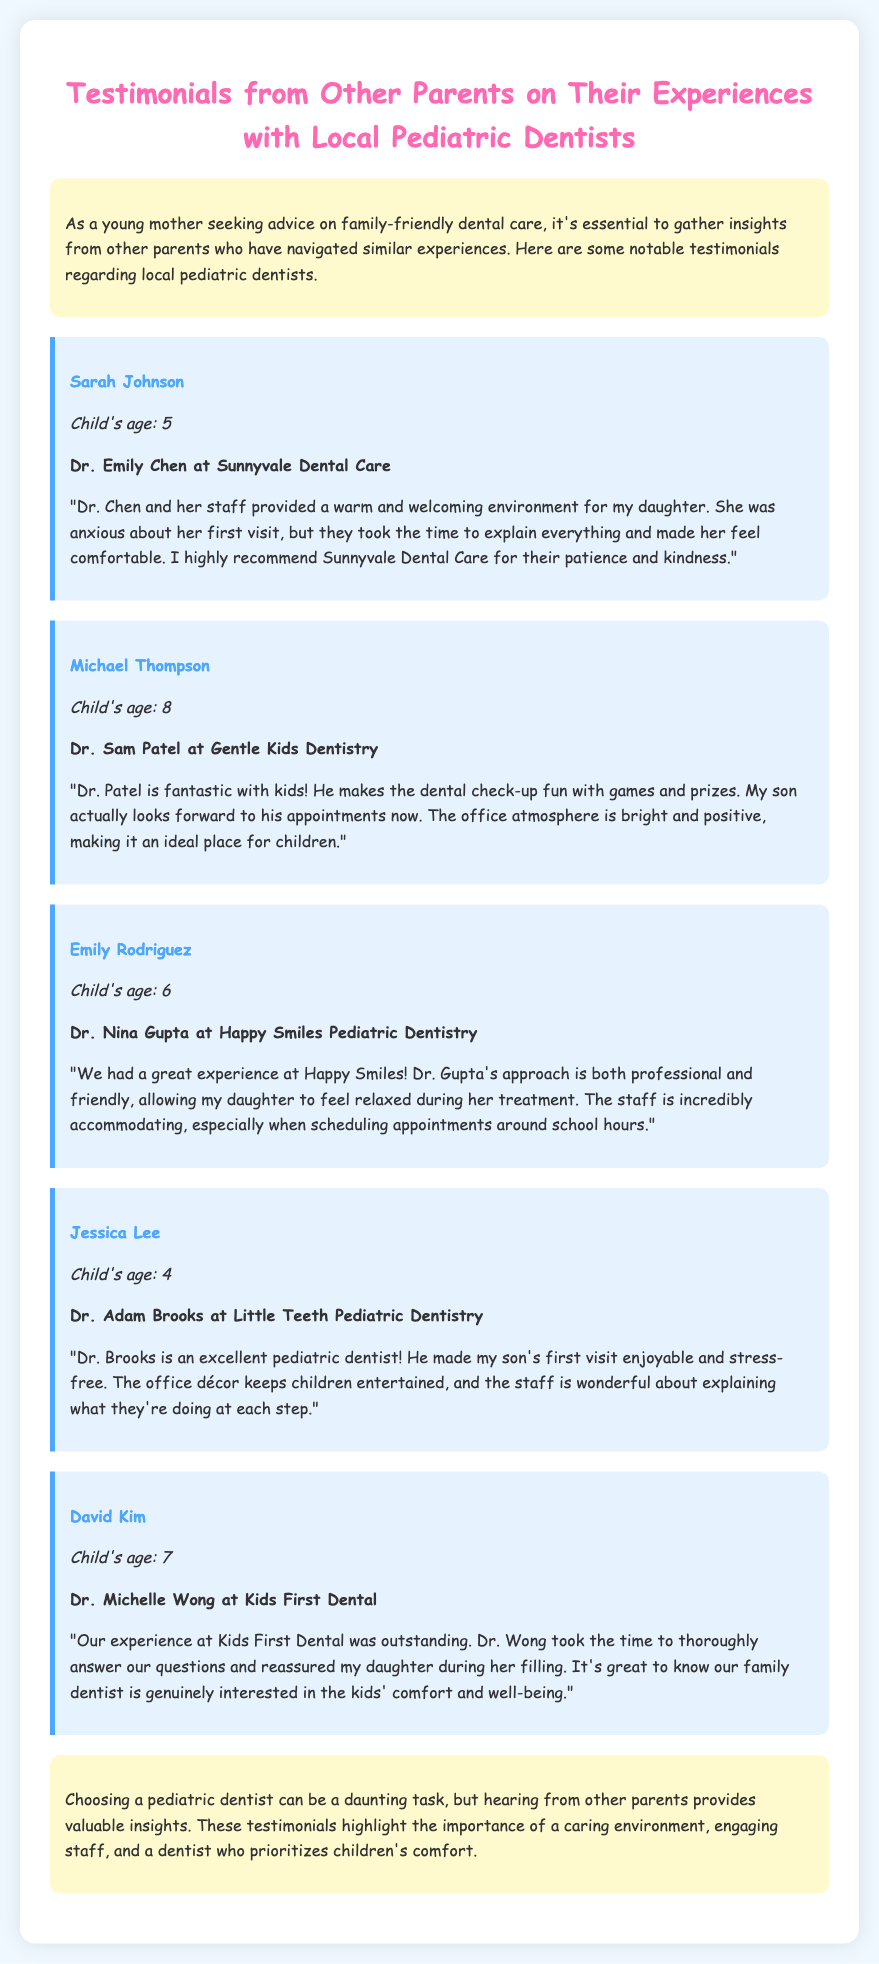What is the name of the first dentist mentioned? The first dentist mentioned in the document is Dr. Emily Chen at Sunnyvale Dental Care.
Answer: Dr. Emily Chen How old is Sarah Johnson's child? The document specifies that Sarah Johnson's child is 5 years old.
Answer: 5 Which pediatric dentist is associated with a fun atmosphere? Michael Thompson's testimonial highlights that Dr. Sam Patel creates a fun atmosphere during check-ups.
Answer: Dr. Sam Patel What was Jessica Lee's son's experience during his first visit? Jessica Lee mentions that her son's first visit was enjoyable and stress-free with Dr. Brooks.
Answer: Enjoyable and stress-free How many testimonials are included in the document? The document contains five testimonials from different parents regarding their experiences with pediatric dentists.
Answer: Five What is a common theme mentioned across the testimonials? The testimonials emphasize the importance of a caring environment and staff engagement for children's comfort.
Answer: Caring environment Which dentist provided a positive experience specifically for a child's filling? David Kim's testimonial describes Dr. Michelle Wong as providing reassurance during his daughter's filling.
Answer: Dr. Michelle Wong What type of document is this? The document is a memo featuring testimonials from parents about local pediatric dentists.
Answer: Memo 